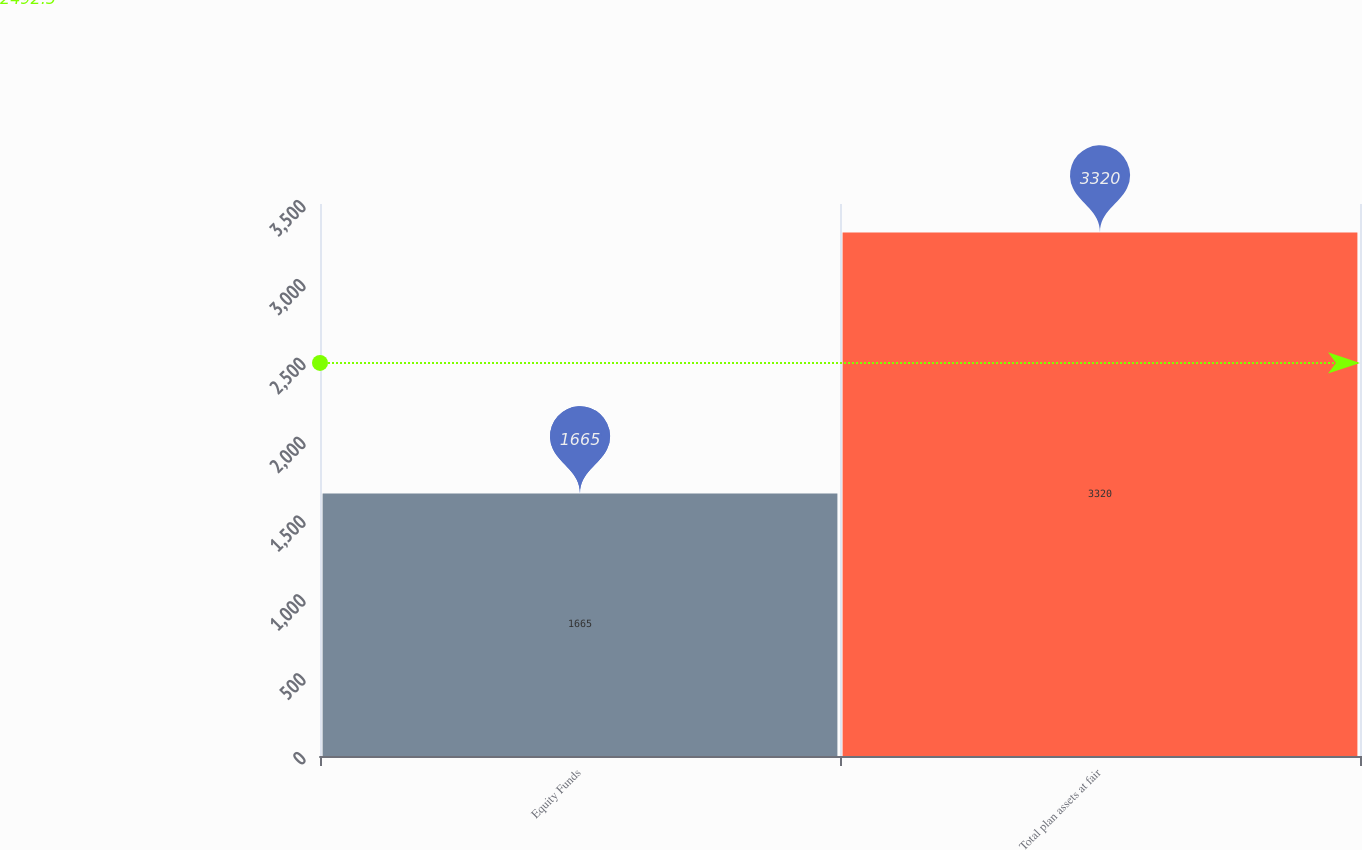Convert chart. <chart><loc_0><loc_0><loc_500><loc_500><bar_chart><fcel>Equity Funds<fcel>Total plan assets at fair<nl><fcel>1665<fcel>3320<nl></chart> 